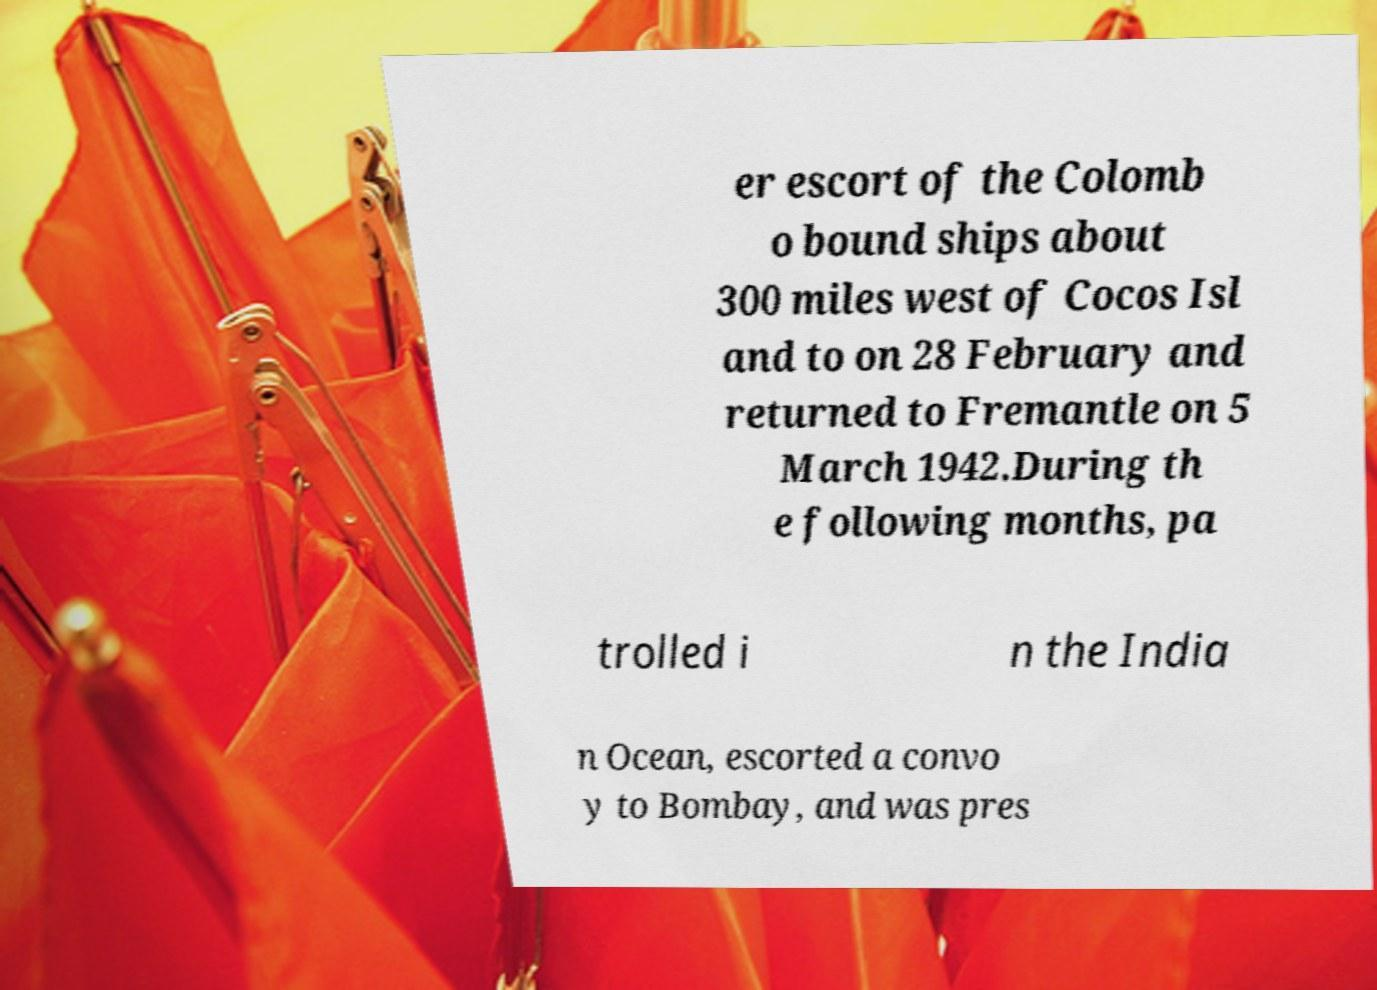I need the written content from this picture converted into text. Can you do that? er escort of the Colomb o bound ships about 300 miles west of Cocos Isl and to on 28 February and returned to Fremantle on 5 March 1942.During th e following months, pa trolled i n the India n Ocean, escorted a convo y to Bombay, and was pres 